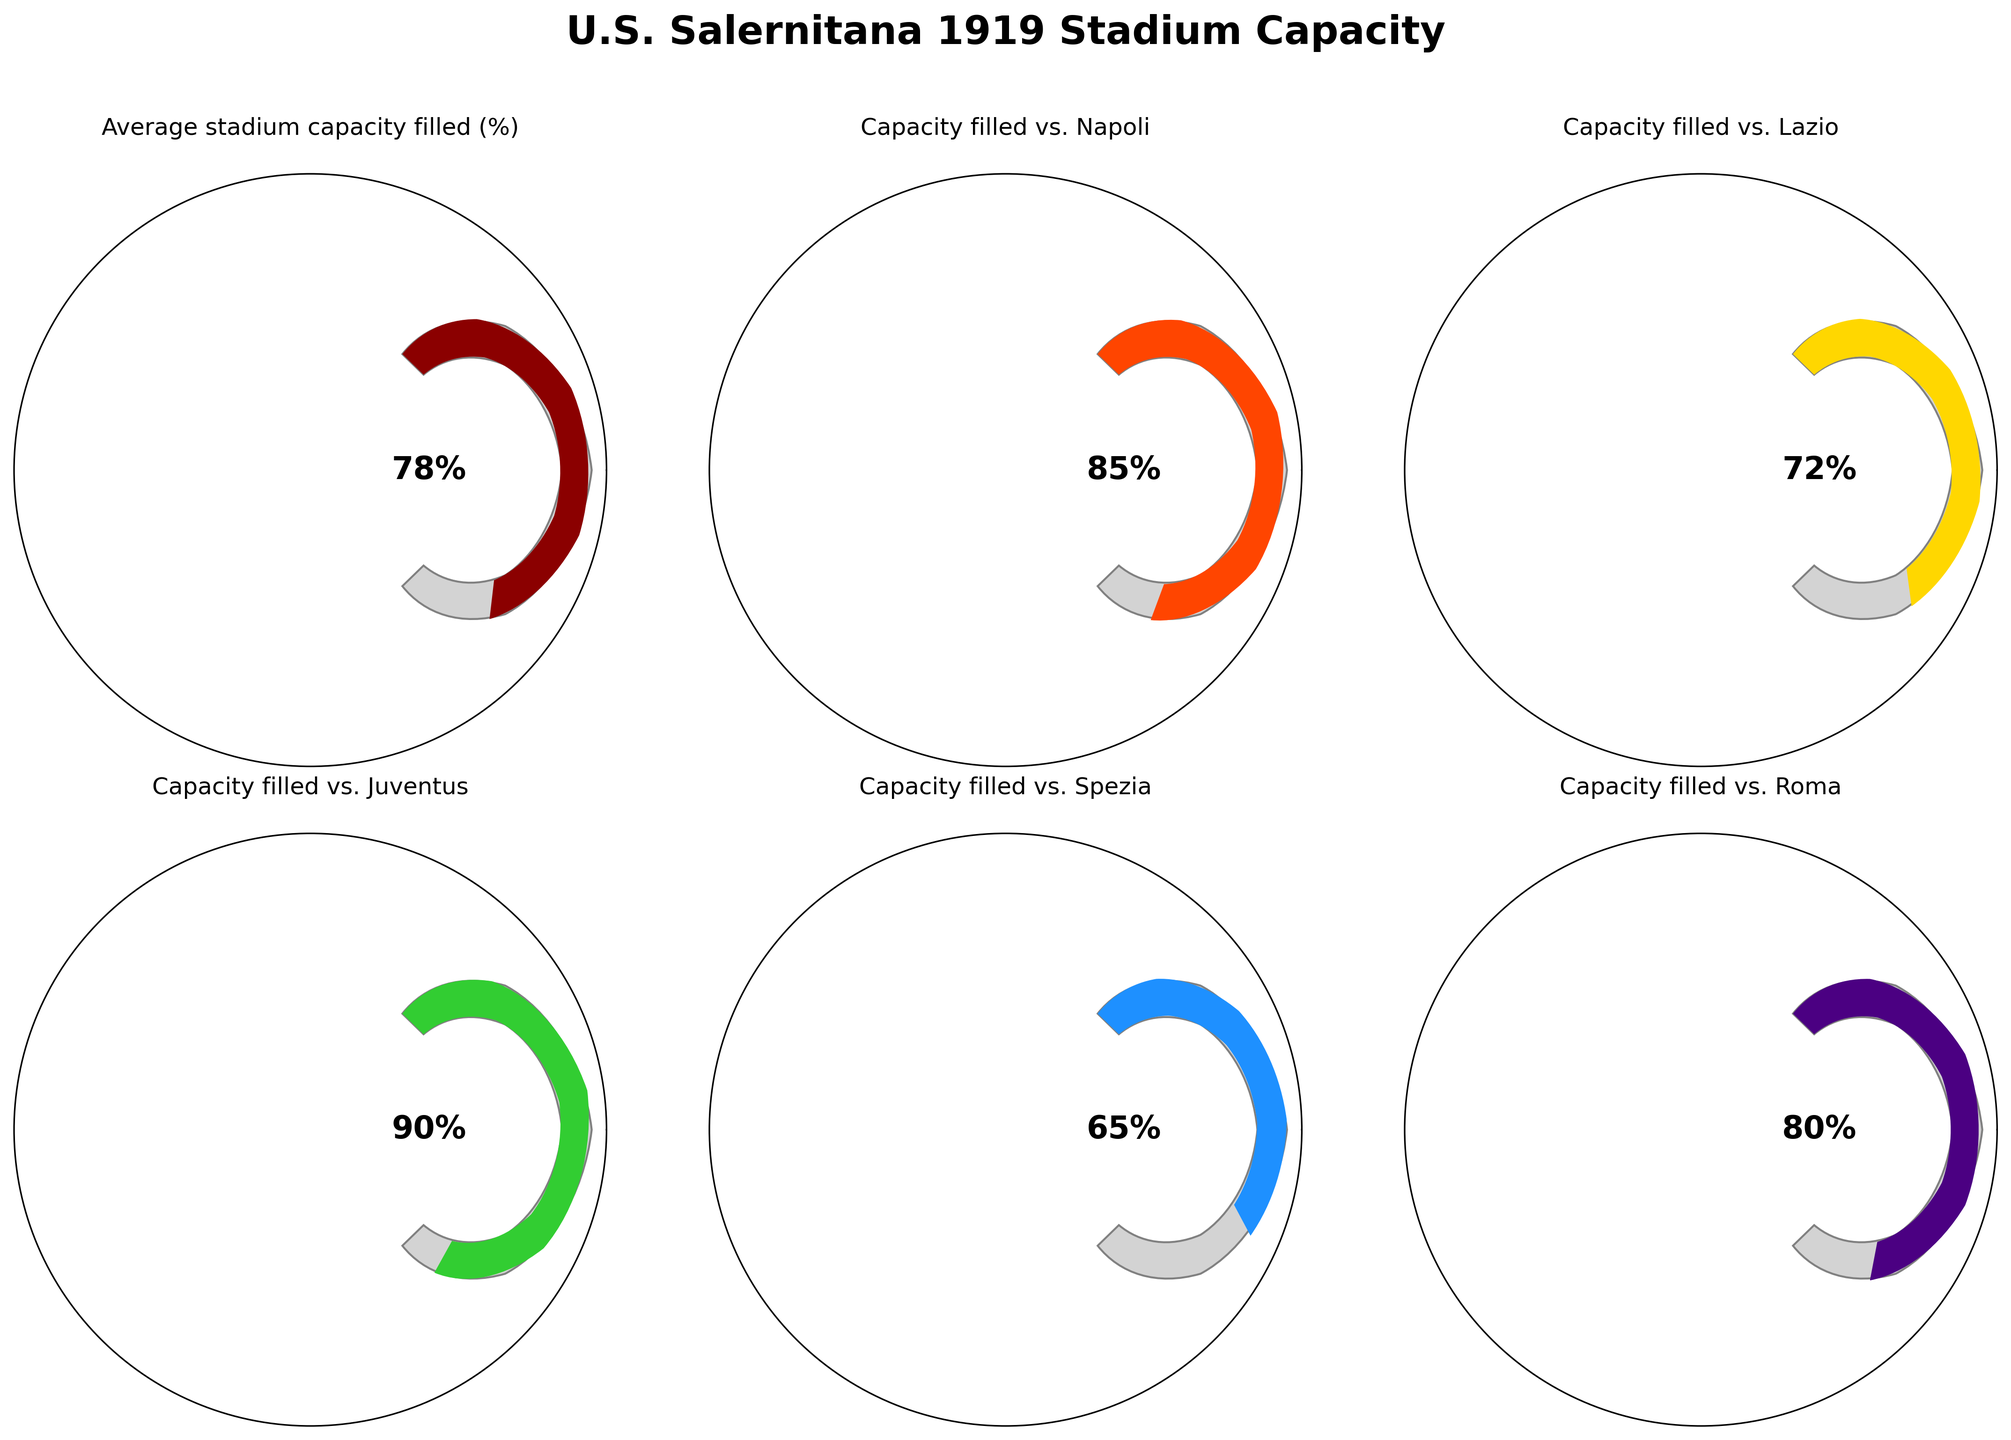What's the average percentage of stadium capacity filled during U.S. Salernitana 1919's home games? To find this, look for the gauge chart labeled "Average stadium capacity filled (%)". The value displayed on this chart represents the average.
Answer: 78% Which match had the highest capacity filled? To find this, compare the values on each of the gauge charts. Look for the highest value displayed among them.
Answer: vs. Juventus How does the capacity filled against Roma compare to the average? Look for the gauge charts labeled "Average stadium capacity filled (%)" and "Capacity filled vs. Roma". Compare the values from these two charts.
Answer: 80% vs. 78% What's the difference in capacity filled between the match against Lazio and the match against Spezia? Look at the gauge charts for "Capacity filled vs. Lazio" and "Capacity filled vs. Spezia". Subtract the value of the Spezia match from the Lazio match.
Answer: 72% - 65% = 7% Which team did U.S. Salernitana 1919 play when the stadium was filled to 85% capacity? Refer to the gauge chart with a value of 85%. Check the label associated with that specific chart.
Answer: Napoli How many matches had a stadium capacity fill rate above 75%? Count the number of gauge charts that have a value exceeding 75%.
Answer: 4 What is the difference between the lowest and highest recorded percentages of stadium capacity filled? Compare the smallest and largest values among all gauge charts and calculate the difference.
Answer: 90% - 65% = 25% Between the matches against Roma and Lazio, which one had a higher capacity filled? Compare the values on the gauge charts labeled "Capacity filled vs. Roma" and "Capacity filled vs. Lazio".
Answer: Roma What is the median value of the stadium capacities filled for the listed matches? List the values (85, 72, 90, 65, 80), sort them (65, 72, 80, 85, 90), and find the middle value.
Answer: 80% If the stadium has 20,000 seats, approximately how many seats were filled during the match against Juventus? Use the percentage filled for the Juventus match (90%). Calculate 90% of 20,000 seats.
Answer: 18,000 seats 